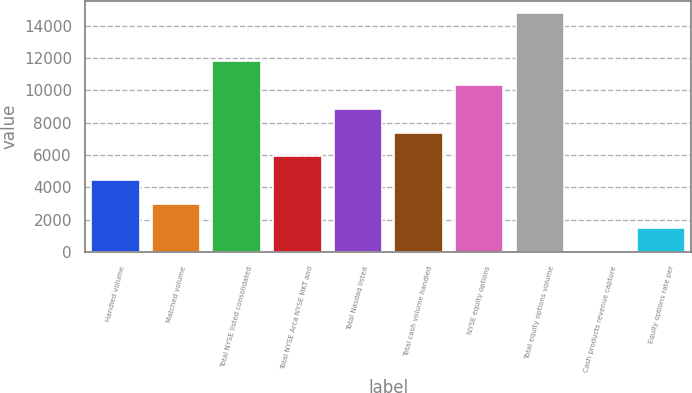Convert chart to OTSL. <chart><loc_0><loc_0><loc_500><loc_500><bar_chart><fcel>Handled volume<fcel>Matched volume<fcel>Total NYSE listed consolidated<fcel>Total NYSE Arca NYSE MKT and<fcel>Total Nasdaq listed<fcel>Total cash volume handled<fcel>NYSE equity options<fcel>Total equity options volume<fcel>Cash products revenue capture<fcel>Equity options rate per<nl><fcel>4437.93<fcel>2958.64<fcel>11834.4<fcel>5917.23<fcel>8875.82<fcel>7396.52<fcel>10355.1<fcel>14793<fcel>0.05<fcel>1479.35<nl></chart> 